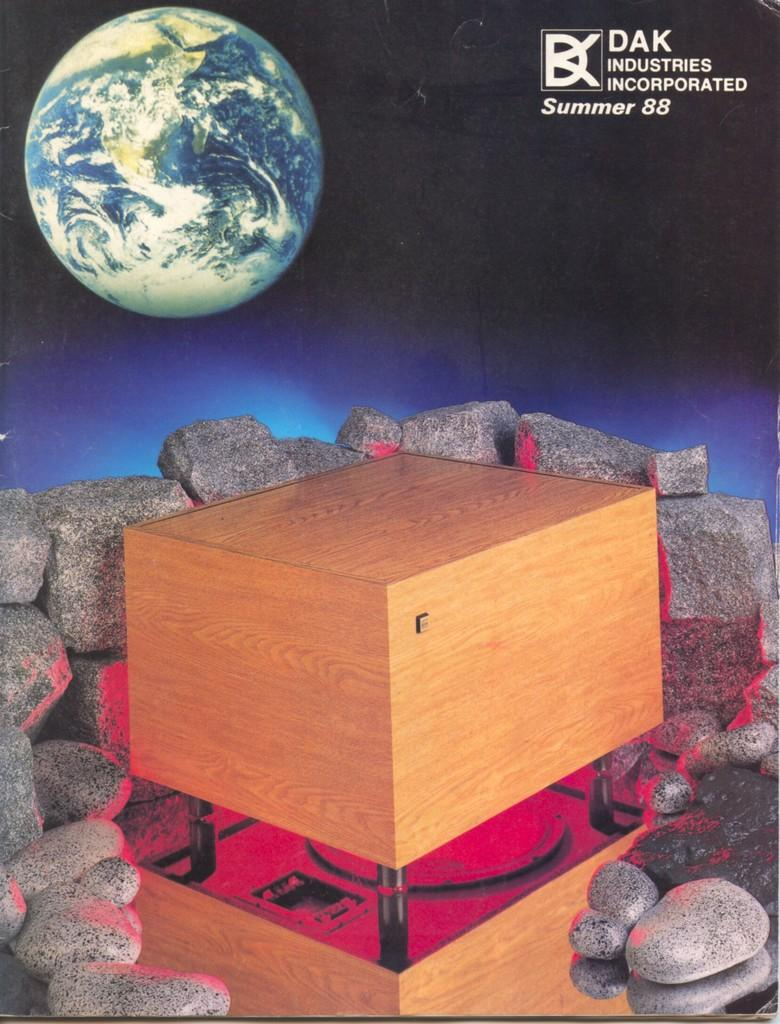What type of image is in the center of the picture? The image contains a graphic image. What object can be seen in the image besides the graphic? There is a box in the image. What surrounds the box in the image? Stones are present around the box. What celestial body is visible in the top left of the image? There is a planet in the top left of the image. What is located in the top right of the image? There is text in the top right of the image. What type of leaf can be seen falling in the image? There is no leaf present in the image. How does the pain affect the graphic in the image? There is no mention of pain in the image, and the graphic is not affected by any pain. 